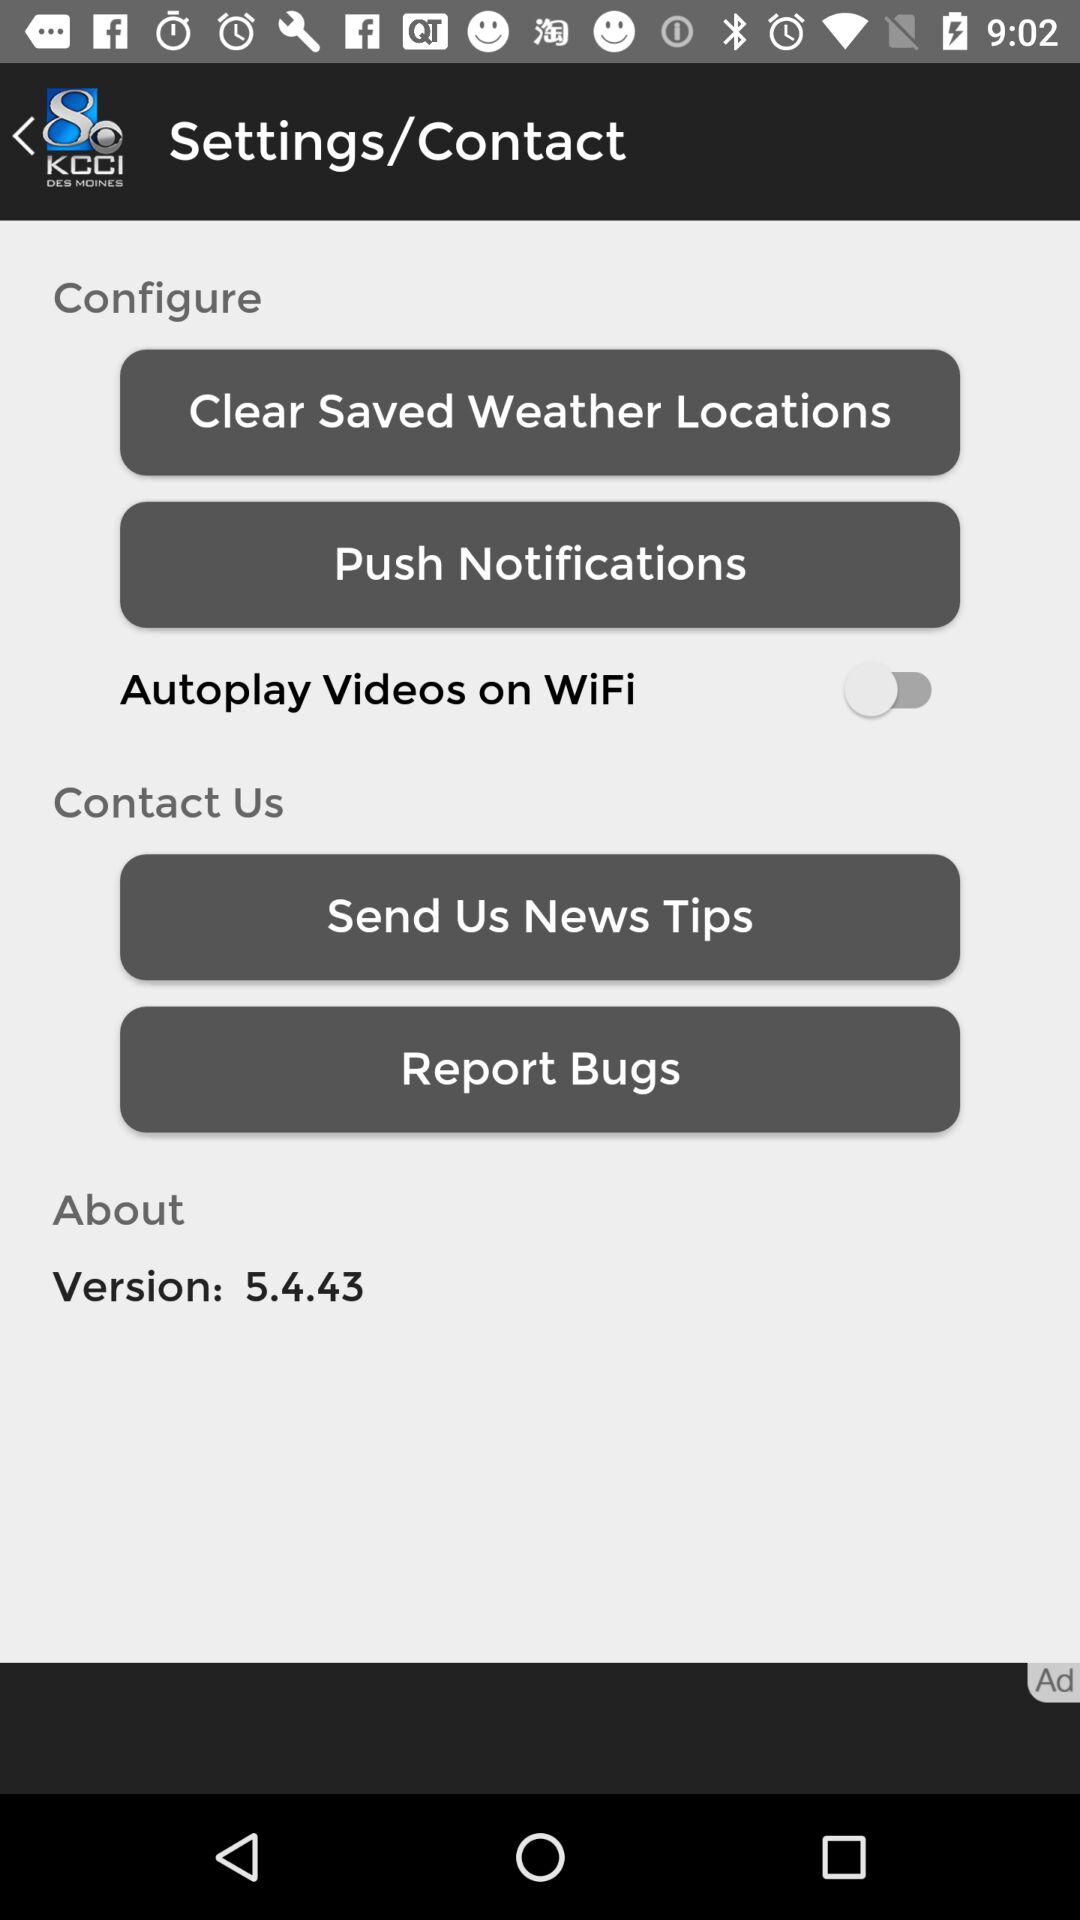What is the version of the application? The version of the application is 5.4.43. 